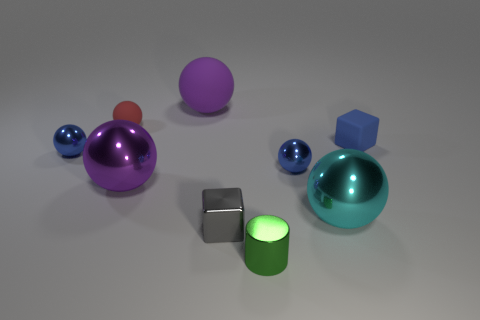How would you compare the size of the largest object to the smallest object in the image? The largest object in the image is the dome-shaped item on the right, which is significantly larger than the smallest objects, which are the three small cyan and blue balls. There's a considerable size difference, making the dome-shaped object appear quite dominant in the scene. 